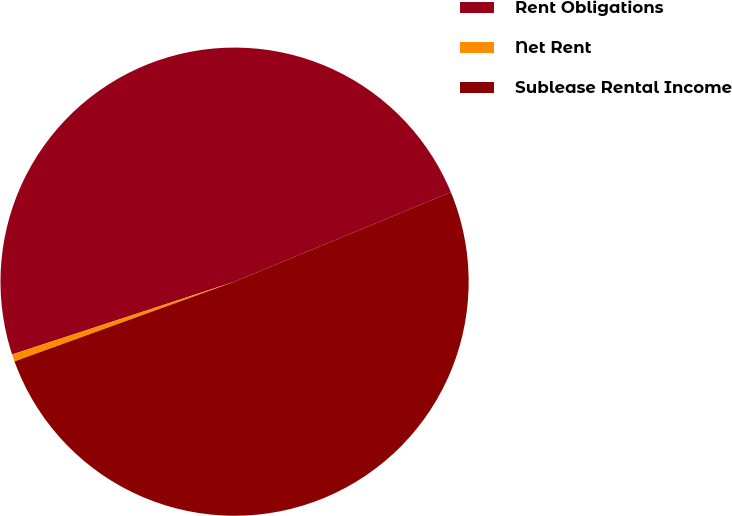Convert chart. <chart><loc_0><loc_0><loc_500><loc_500><pie_chart><fcel>Rent Obligations<fcel>Net Rent<fcel>Sublease Rental Income<nl><fcel>48.79%<fcel>0.5%<fcel>50.71%<nl></chart> 